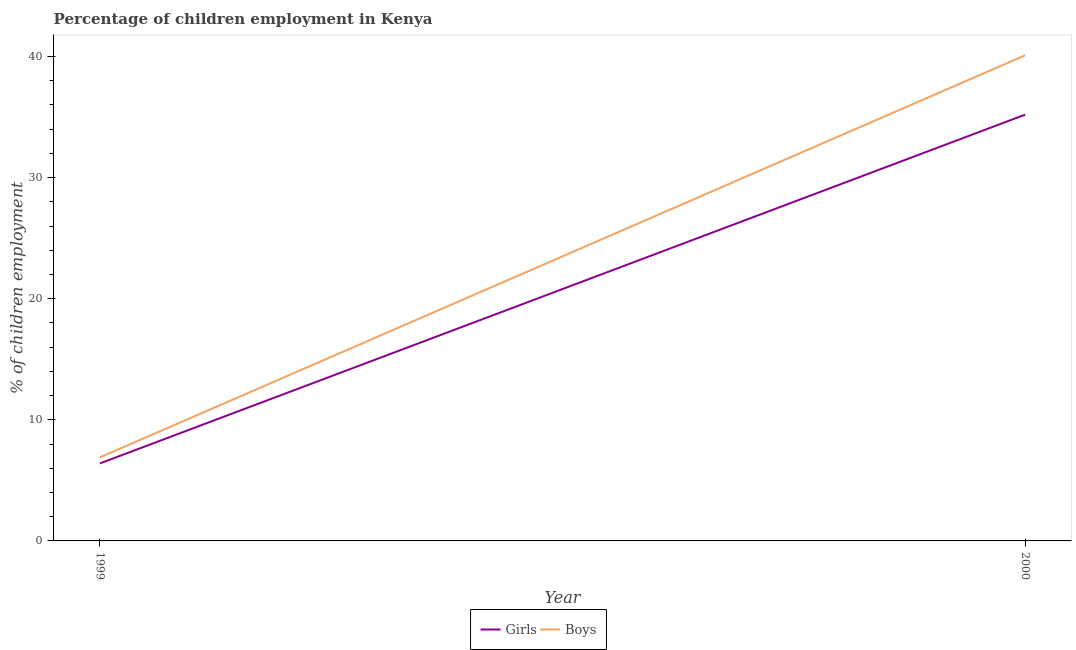How many different coloured lines are there?
Provide a succinct answer. 2. Is the number of lines equal to the number of legend labels?
Your response must be concise. Yes. What is the percentage of employed girls in 2000?
Your response must be concise. 35.2. Across all years, what is the maximum percentage of employed boys?
Your answer should be very brief. 40.1. Across all years, what is the minimum percentage of employed boys?
Provide a short and direct response. 6.9. In which year was the percentage of employed boys maximum?
Provide a short and direct response. 2000. What is the total percentage of employed girls in the graph?
Offer a very short reply. 41.6. What is the difference between the percentage of employed boys in 1999 and that in 2000?
Ensure brevity in your answer.  -33.2. What is the difference between the percentage of employed girls in 2000 and the percentage of employed boys in 1999?
Your answer should be compact. 28.3. In the year 2000, what is the difference between the percentage of employed boys and percentage of employed girls?
Offer a very short reply. 4.9. In how many years, is the percentage of employed boys greater than 8 %?
Your response must be concise. 1. What is the ratio of the percentage of employed girls in 1999 to that in 2000?
Provide a succinct answer. 0.18. Is the percentage of employed boys strictly less than the percentage of employed girls over the years?
Provide a short and direct response. No. How many years are there in the graph?
Keep it short and to the point. 2. Does the graph contain grids?
Offer a very short reply. No. Where does the legend appear in the graph?
Ensure brevity in your answer.  Bottom center. How many legend labels are there?
Give a very brief answer. 2. What is the title of the graph?
Your answer should be very brief. Percentage of children employment in Kenya. What is the label or title of the Y-axis?
Ensure brevity in your answer.  % of children employment. What is the % of children employment of Girls in 2000?
Provide a short and direct response. 35.2. What is the % of children employment of Boys in 2000?
Provide a short and direct response. 40.1. Across all years, what is the maximum % of children employment in Girls?
Offer a terse response. 35.2. Across all years, what is the maximum % of children employment of Boys?
Keep it short and to the point. 40.1. Across all years, what is the minimum % of children employment in Boys?
Your answer should be compact. 6.9. What is the total % of children employment in Girls in the graph?
Your answer should be compact. 41.6. What is the total % of children employment of Boys in the graph?
Ensure brevity in your answer.  47. What is the difference between the % of children employment in Girls in 1999 and that in 2000?
Provide a succinct answer. -28.8. What is the difference between the % of children employment in Boys in 1999 and that in 2000?
Ensure brevity in your answer.  -33.2. What is the difference between the % of children employment of Girls in 1999 and the % of children employment of Boys in 2000?
Offer a very short reply. -33.7. What is the average % of children employment in Girls per year?
Offer a very short reply. 20.8. What is the ratio of the % of children employment in Girls in 1999 to that in 2000?
Provide a succinct answer. 0.18. What is the ratio of the % of children employment of Boys in 1999 to that in 2000?
Provide a succinct answer. 0.17. What is the difference between the highest and the second highest % of children employment of Girls?
Offer a terse response. 28.8. What is the difference between the highest and the second highest % of children employment of Boys?
Ensure brevity in your answer.  33.2. What is the difference between the highest and the lowest % of children employment of Girls?
Your answer should be very brief. 28.8. What is the difference between the highest and the lowest % of children employment in Boys?
Your answer should be very brief. 33.2. 